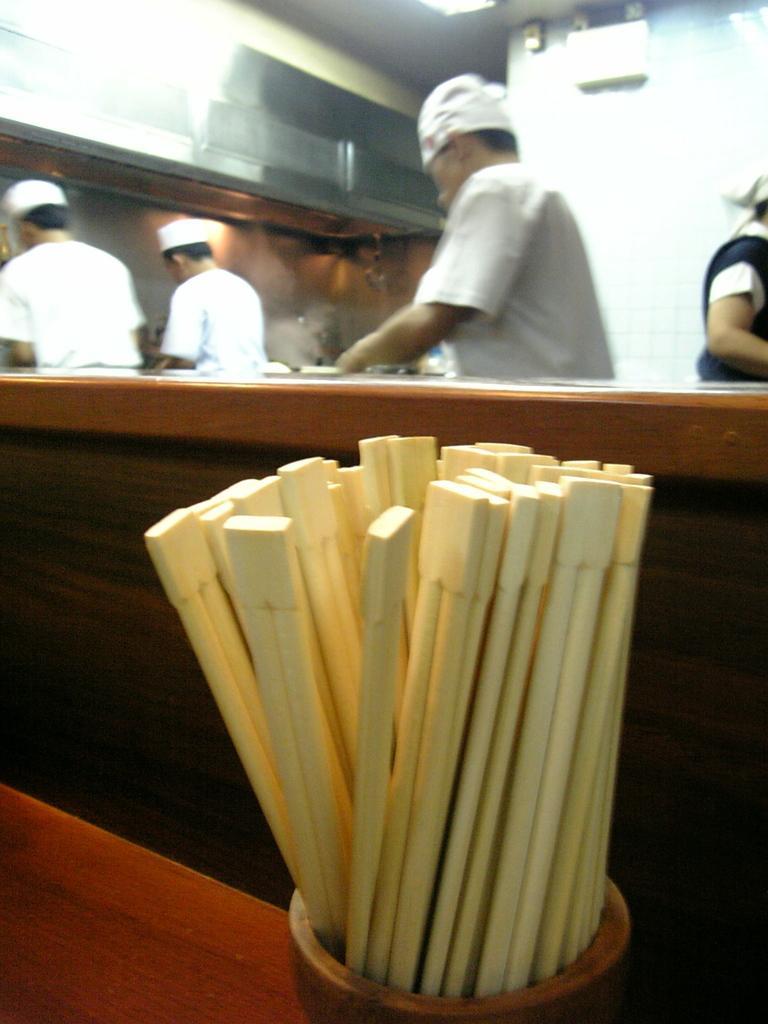In one or two sentences, can you explain what this image depicts? In this picture we can see four persons standing wore cap and they are doing some kitchen activity and in front we can see sticks in some wooden bowl. 